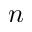<formula> <loc_0><loc_0><loc_500><loc_500>n</formula> 